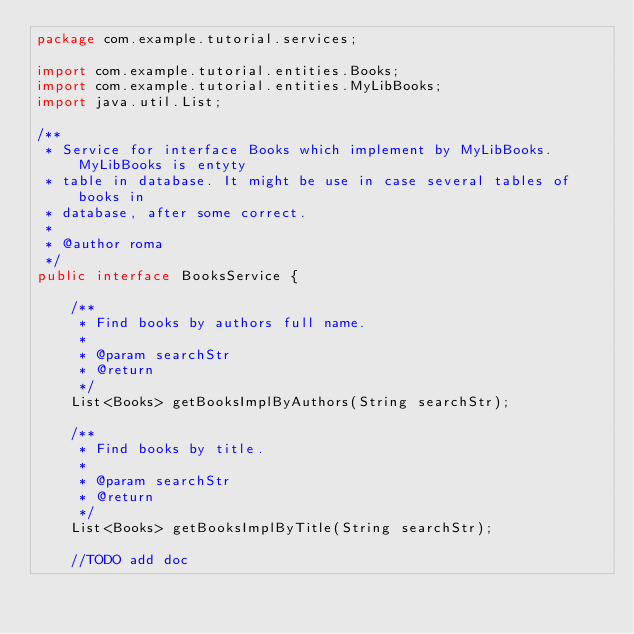<code> <loc_0><loc_0><loc_500><loc_500><_Java_>package com.example.tutorial.services;

import com.example.tutorial.entities.Books;
import com.example.tutorial.entities.MyLibBooks;
import java.util.List;

/**
 * Service for interface Books which implement by MyLibBooks. MyLibBooks is entyty
 * table in database. It might be use in case several tables of books in 
 * database, after some correct.
 * 
 * @author roma
 */
public interface BooksService {

	/**
	 * Find books by authors full name.
	 *
	 * @param searchStr
	 * @return
	 */
	List<Books> getBooksImplByAuthors(String searchStr);

	/**
	 * Find books by title.
	 *
	 * @param searchStr
	 * @return
	 */
	List<Books> getBooksImplByTitle(String searchStr);

	//TODO add doc</code> 